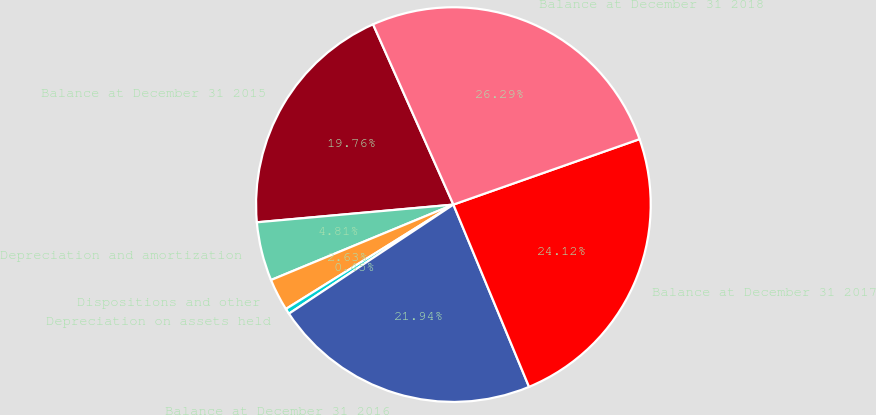Convert chart. <chart><loc_0><loc_0><loc_500><loc_500><pie_chart><fcel>Balance at December 31 2015<fcel>Depreciation and amortization<fcel>Dispositions and other<fcel>Depreciation on assets held<fcel>Balance at December 31 2016<fcel>Balance at December 31 2017<fcel>Balance at December 31 2018<nl><fcel>19.76%<fcel>4.81%<fcel>2.63%<fcel>0.45%<fcel>21.94%<fcel>24.12%<fcel>26.29%<nl></chart> 